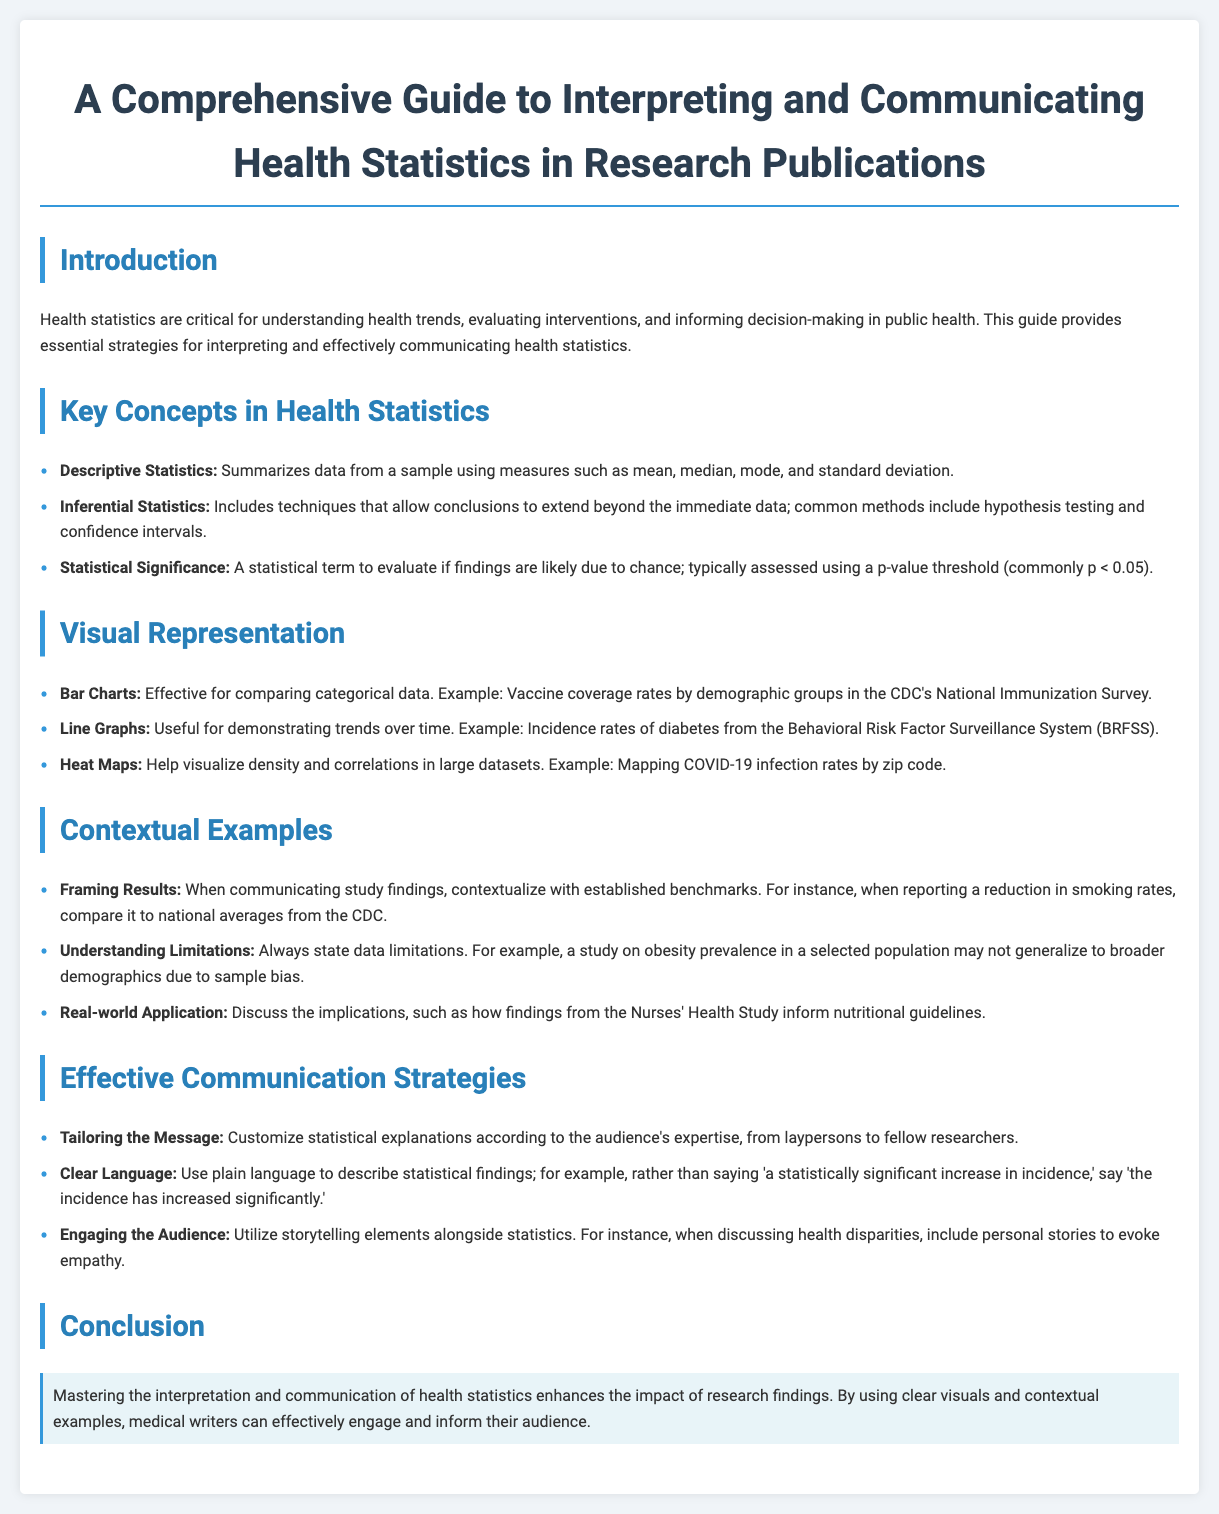What are health statistics critical for? Health statistics are critical for understanding health trends, evaluating interventions, and informing decision-making in public health.
Answer: Understanding health trends What are the common methods of inferential statistics? Common methods of inferential statistics include hypothesis testing and confidence intervals.
Answer: Hypothesis testing and confidence intervals What type of chart is effective for comparing categorical data? Bar charts are effective for comparing categorical data.
Answer: Bar charts Which type of graph is useful for demonstrating trends over time? Line graphs are useful for demonstrating trends over time.
Answer: Line graphs What should be included when communicating study findings? Contextualize with established benchmarks should be included when communicating study findings.
Answer: Contextualize with established benchmarks What should be stated regarding data findings? Always state data limitations regarding data findings.
Answer: Data limitations How should statistical explanations be customized? Statistical explanations should be customized according to the audience's expertise.
Answer: According to the audience's expertise What is the main takeaway from the conclusion? Mastering the interpretation and communication of health statistics enhances the impact of research findings.
Answer: Enhances the impact of research findings 